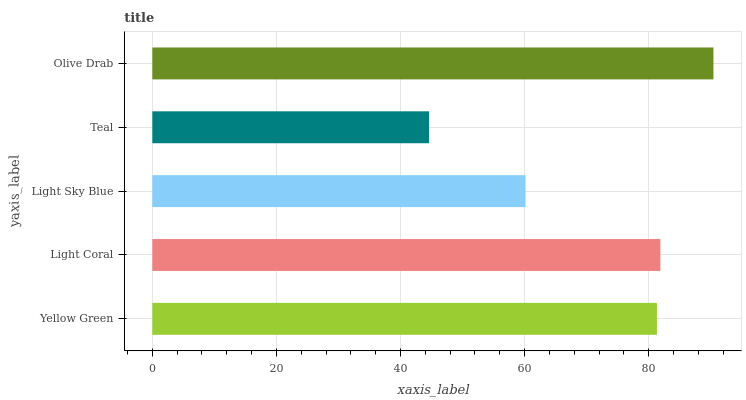Is Teal the minimum?
Answer yes or no. Yes. Is Olive Drab the maximum?
Answer yes or no. Yes. Is Light Coral the minimum?
Answer yes or no. No. Is Light Coral the maximum?
Answer yes or no. No. Is Light Coral greater than Yellow Green?
Answer yes or no. Yes. Is Yellow Green less than Light Coral?
Answer yes or no. Yes. Is Yellow Green greater than Light Coral?
Answer yes or no. No. Is Light Coral less than Yellow Green?
Answer yes or no. No. Is Yellow Green the high median?
Answer yes or no. Yes. Is Yellow Green the low median?
Answer yes or no. Yes. Is Light Coral the high median?
Answer yes or no. No. Is Olive Drab the low median?
Answer yes or no. No. 